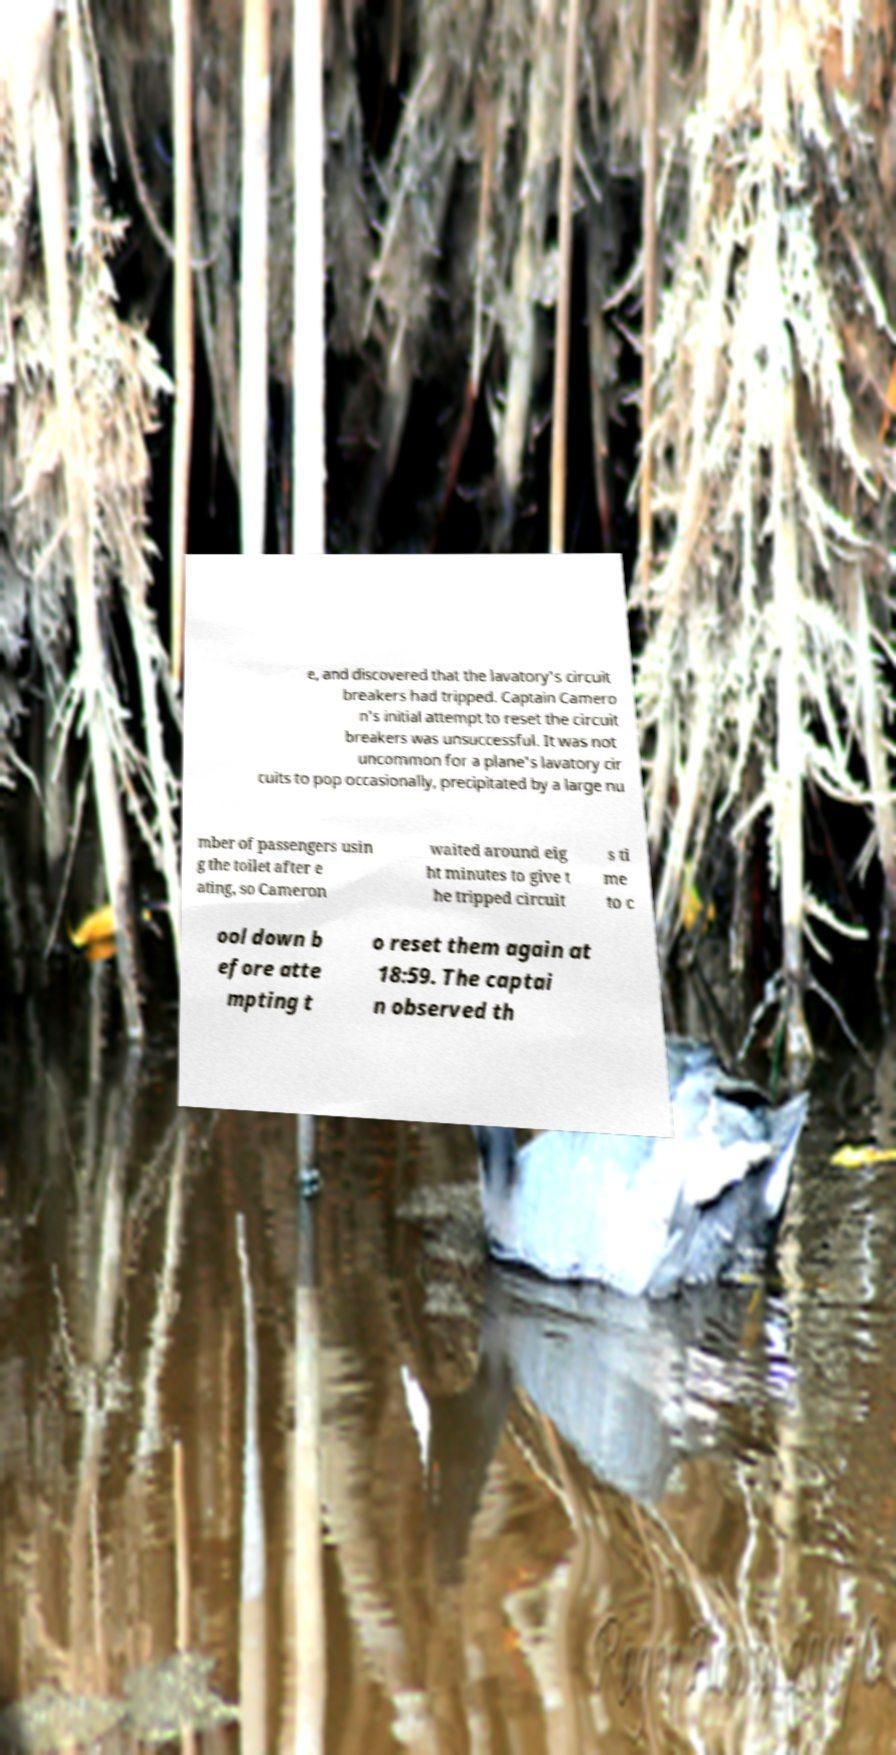Can you accurately transcribe the text from the provided image for me? e, and discovered that the lavatory's circuit breakers had tripped. Captain Camero n's initial attempt to reset the circuit breakers was unsuccessful. It was not uncommon for a plane's lavatory cir cuits to pop occasionally, precipitated by a large nu mber of passengers usin g the toilet after e ating, so Cameron waited around eig ht minutes to give t he tripped circuit s ti me to c ool down b efore atte mpting t o reset them again at 18:59. The captai n observed th 